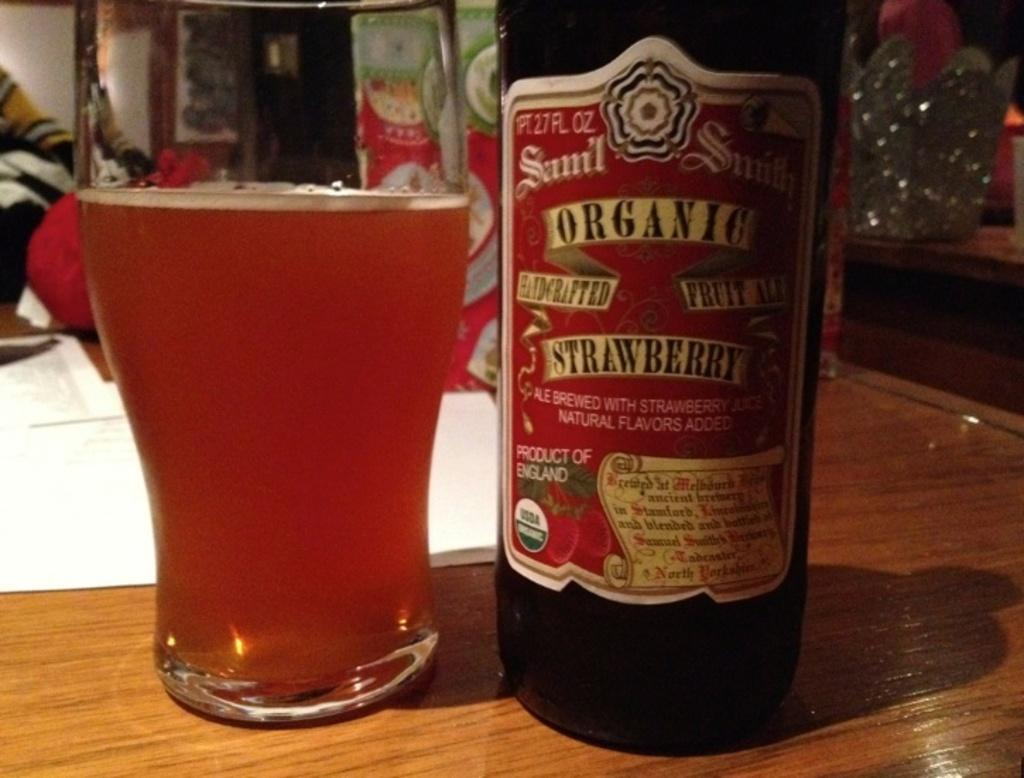<image>
Present a compact description of the photo's key features. A  glass next to a bottle, the word Organic being visible on the bottle. 